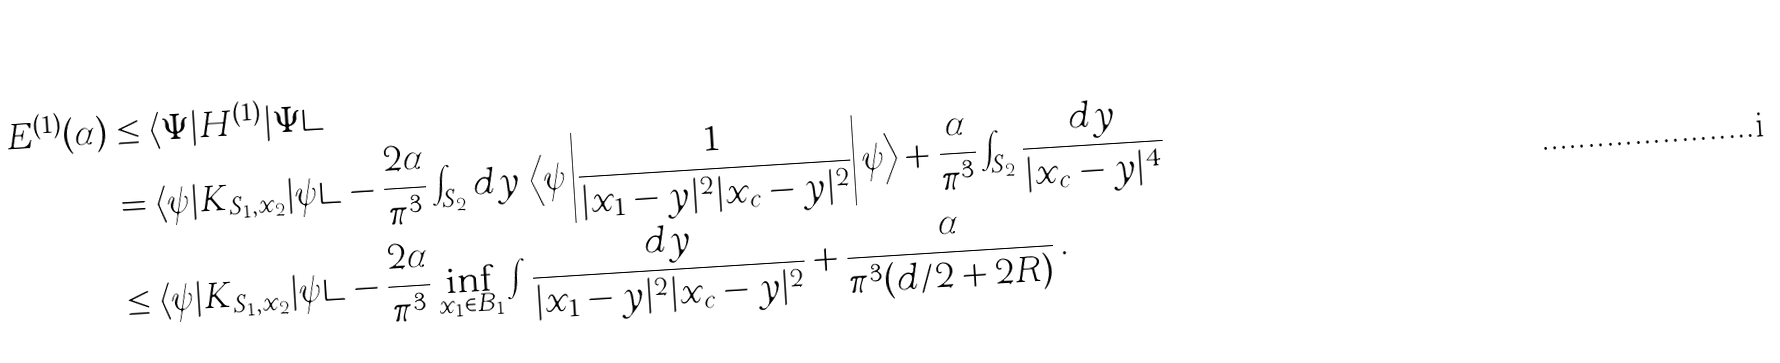Convert formula to latex. <formula><loc_0><loc_0><loc_500><loc_500>E ^ { ( 1 ) } ( \alpha ) & \leq \langle \Psi | H ^ { ( 1 ) } | \Psi \rangle \\ & = \langle \psi | K _ { S _ { 1 } , x _ { 2 } } | \psi \rangle - \frac { 2 \alpha } { \pi ^ { 3 } } \int _ { S _ { 2 } } d y \, \left \langle \psi \left | \frac { 1 } { | x _ { 1 } - y | ^ { 2 } | x _ { c } - y | ^ { 2 } } \right | \psi \right \rangle + \frac { \alpha } { \pi ^ { 3 } } \int _ { S _ { 2 } } \frac { d y } { | x _ { c } - y | ^ { 4 } } \\ & \leq \langle \psi | K _ { S _ { 1 } , x _ { 2 } } | \psi \rangle - \frac { 2 \alpha } { \pi ^ { 3 } } \inf _ { x _ { 1 } \in B _ { 1 } } \int \frac { d y } { | x _ { 1 } - y | ^ { 2 } | x _ { c } - y | ^ { 2 } } + \frac { \alpha } { \pi ^ { 3 } ( d / 2 + 2 R ) } \, .</formula> 